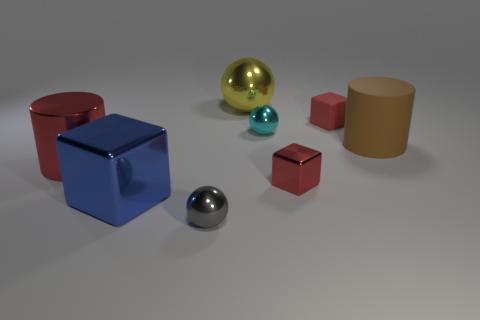Are there any big yellow balls that are in front of the metal block left of the tiny thing that is in front of the blue metallic thing? no 